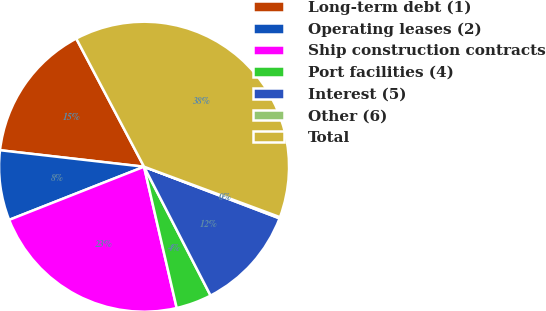Convert chart. <chart><loc_0><loc_0><loc_500><loc_500><pie_chart><fcel>Long-term debt (1)<fcel>Operating leases (2)<fcel>Ship construction contracts<fcel>Port facilities (4)<fcel>Interest (5)<fcel>Other (6)<fcel>Total<nl><fcel>15.44%<fcel>7.79%<fcel>22.64%<fcel>3.97%<fcel>11.62%<fcel>0.14%<fcel>38.4%<nl></chart> 